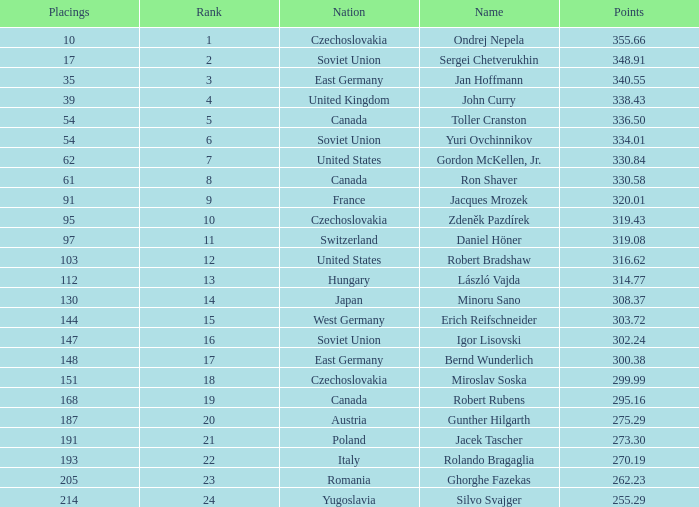How many Placings have Points smaller than 330.84, and a Name of silvo svajger? 1.0. 